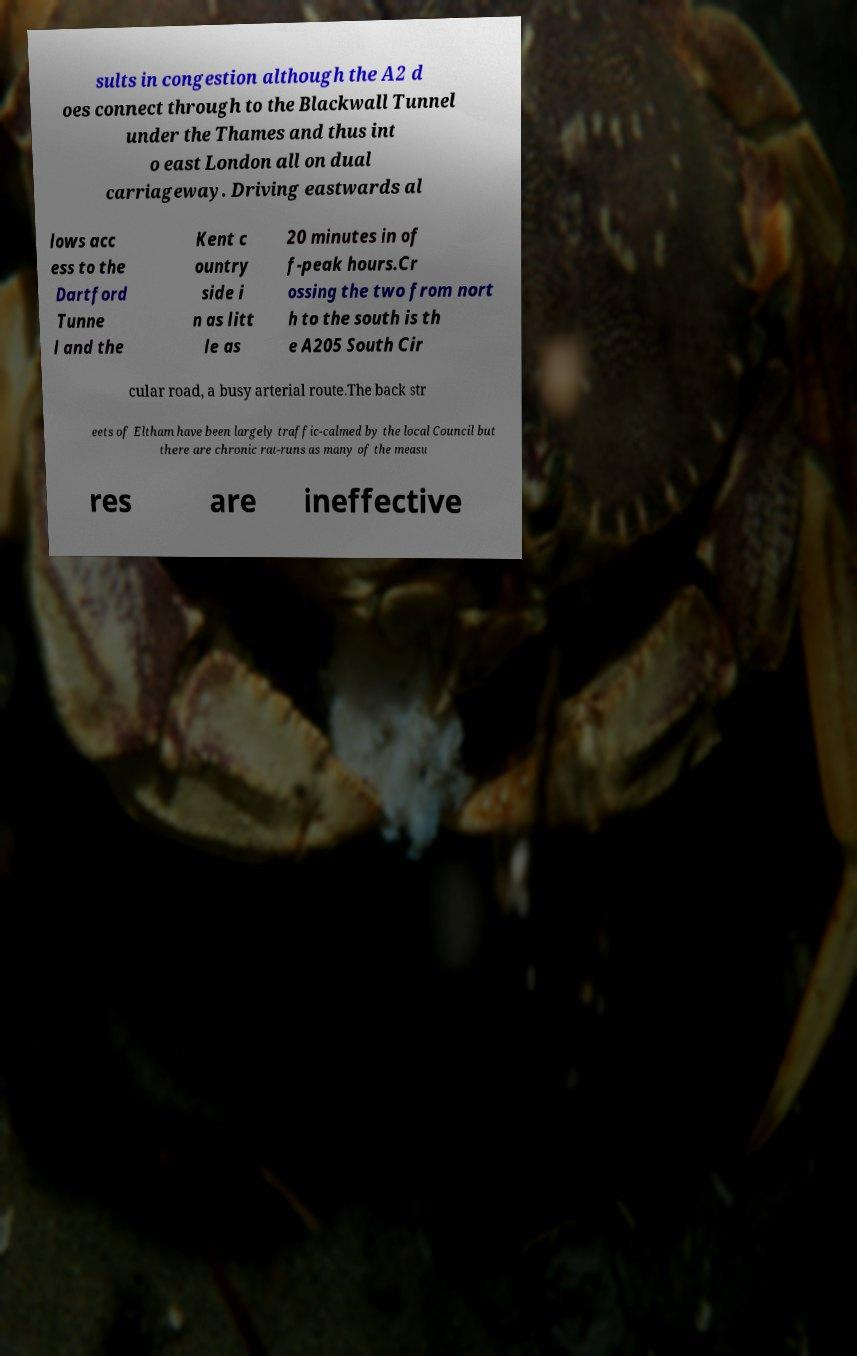Please identify and transcribe the text found in this image. sults in congestion although the A2 d oes connect through to the Blackwall Tunnel under the Thames and thus int o east London all on dual carriageway. Driving eastwards al lows acc ess to the Dartford Tunne l and the Kent c ountry side i n as litt le as 20 minutes in of f-peak hours.Cr ossing the two from nort h to the south is th e A205 South Cir cular road, a busy arterial route.The back str eets of Eltham have been largely traffic-calmed by the local Council but there are chronic rat-runs as many of the measu res are ineffective 